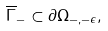Convert formula to latex. <formula><loc_0><loc_0><loc_500><loc_500>\overline { \Gamma } _ { - } \subset \partial \Omega _ { - , - \epsilon } ,</formula> 